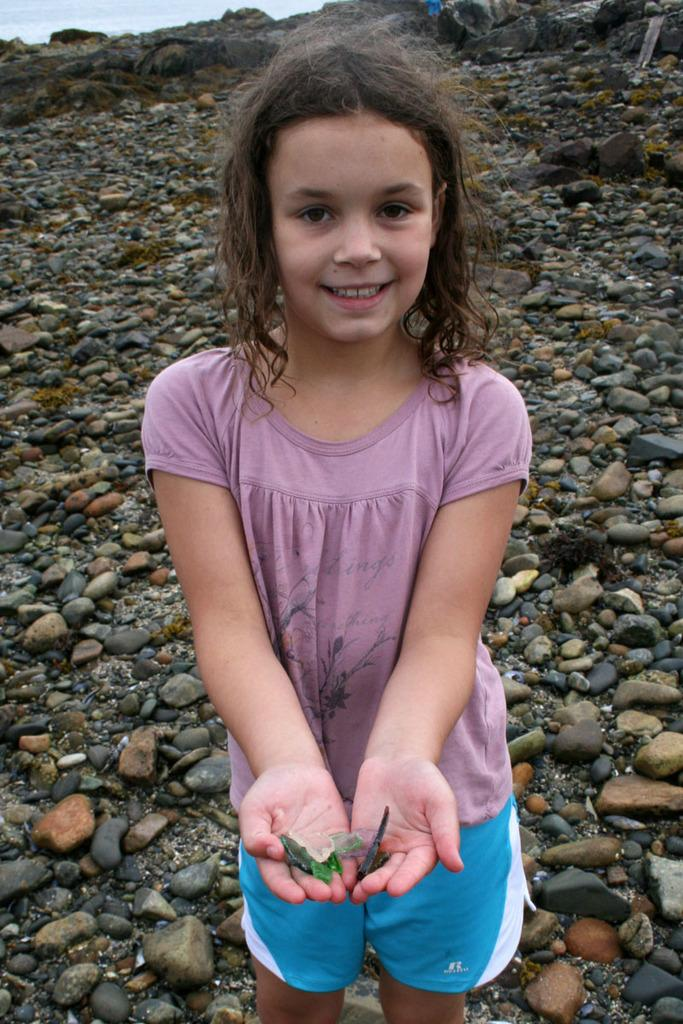Who is the main subject in the image? There is a little girl in the image. What is the little girl doing in the image? The little girl is standing. What can be seen behind the little girl in the image? There are stones behind the little girl. What type of knife is the little girl using to cut the chicken in the image? There is no knife or chicken present in the image; it only features a little girl standing in front of stones. 